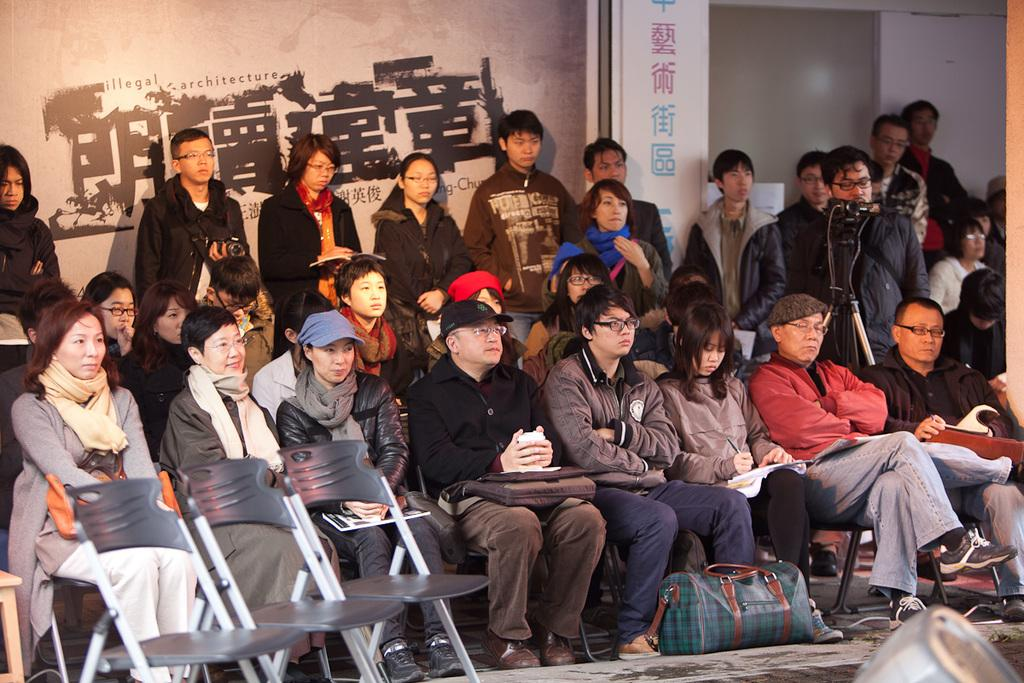What is the group of people doing in the image? The group of people is sitting on a chair in the image. Can you describe the man on the right side of the image? The man on the right side of the image is holding a camera. What is the man doing with the camera? The man is clicking images with the camera. What type of paste is being used by the man to stick the camera to the chair? There is no paste present in the image, and the man is not using any paste to stick the camera to the chair. 